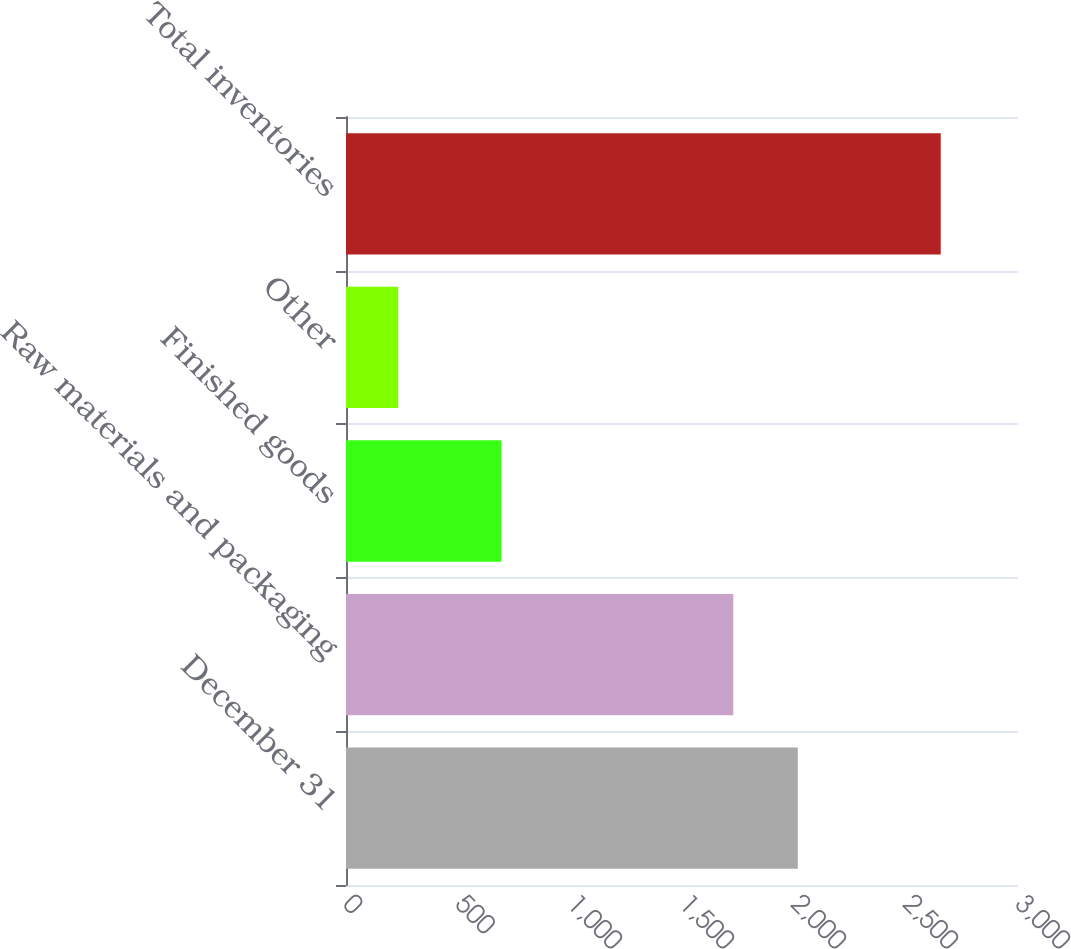Convert chart. <chart><loc_0><loc_0><loc_500><loc_500><bar_chart><fcel>December 31<fcel>Raw materials and packaging<fcel>Finished goods<fcel>Other<fcel>Total inventories<nl><fcel>2017<fcel>1729<fcel>693<fcel>233<fcel>2655<nl></chart> 